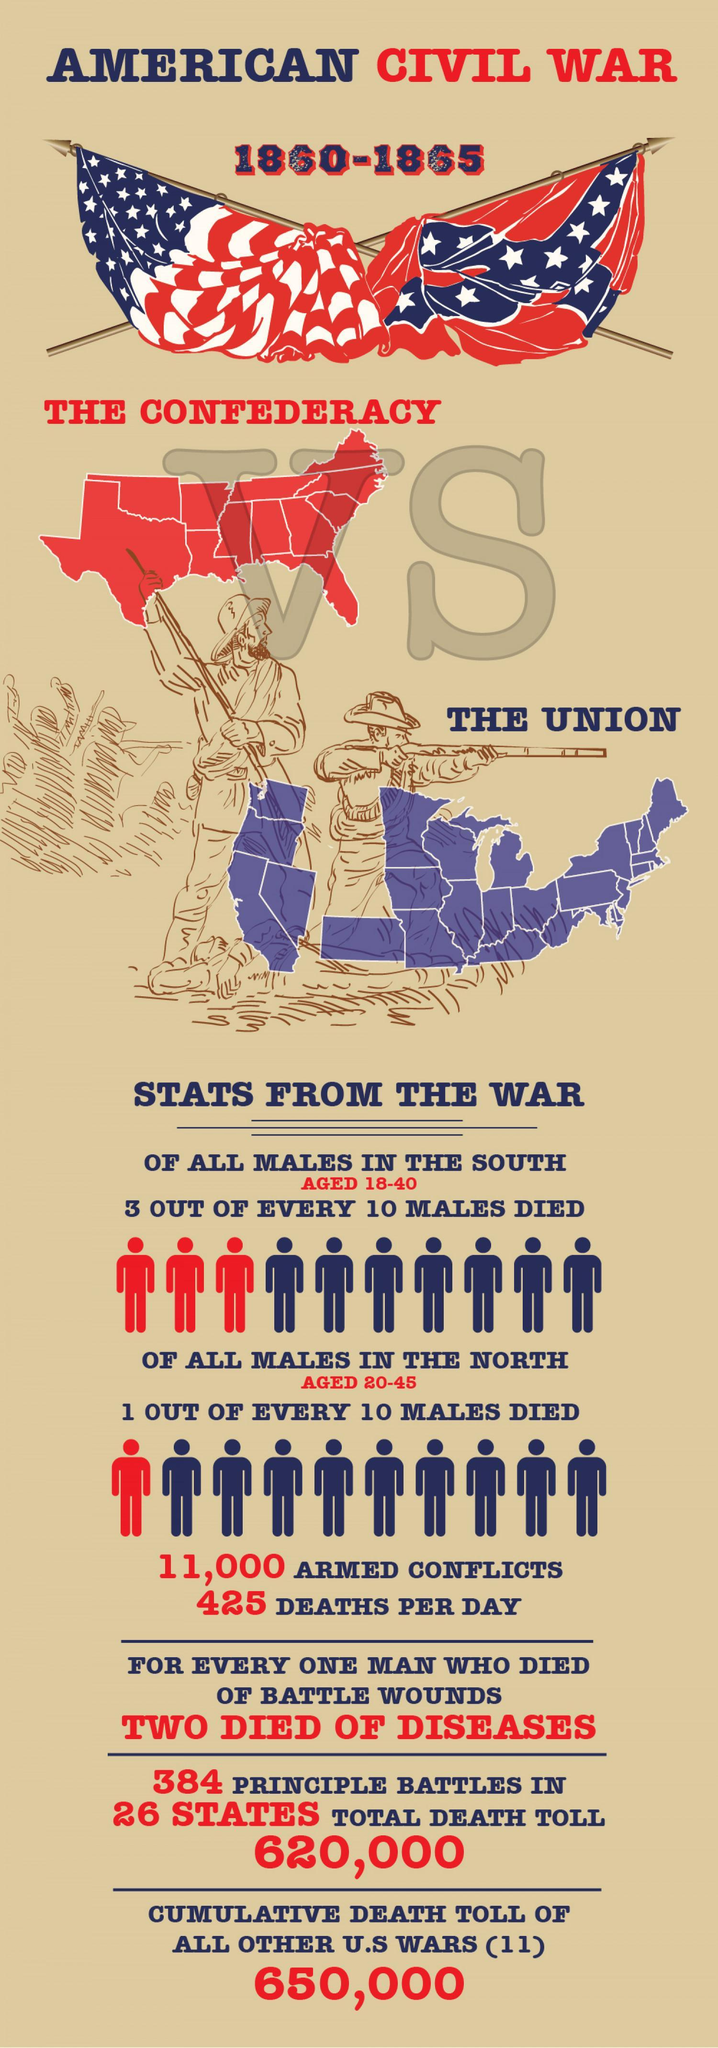Who fought against the Confederates in the Civil War?
Answer the question with a short phrase. THE UNION How many people died per day in the American Civil War? 425 When did the American Civil War end? 1865 